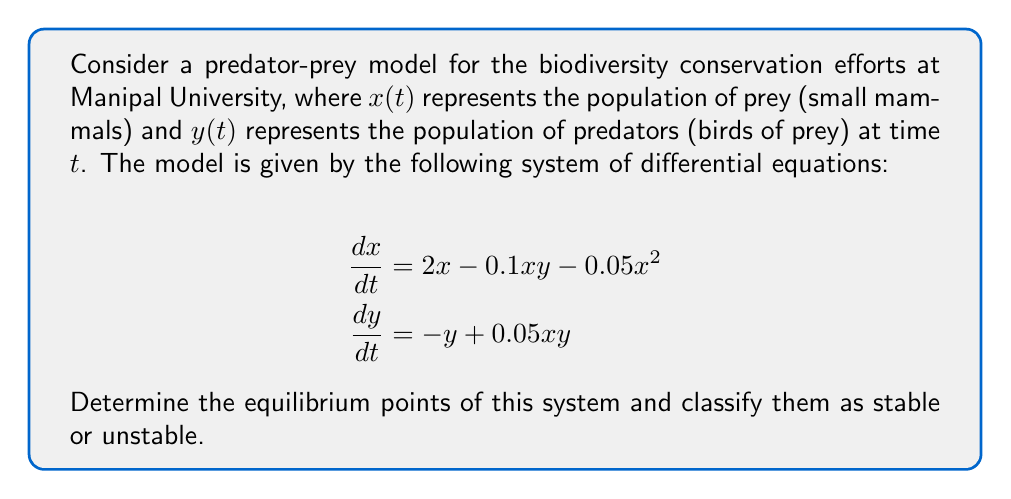Could you help me with this problem? To find the equilibrium points, we set both equations equal to zero and solve for $x$ and $y$:

1) Set $\frac{dx}{dt} = 0$ and $\frac{dy}{dt} = 0$:
   $$\begin{align}
   0 &= 2x - 0.1xy - 0.05x^2 \\
   0 &= -y + 0.05xy
   \end{align}$$

2) From the second equation:
   $y = 0.05xy$
   $y(1 - 0.05x) = 0$
   So, either $y = 0$ or $x = 20$

3) If $y = 0$, substitute into the first equation:
   $0 = 2x - 0.05x^2$
   $x(2 - 0.05x) = 0$
   So, $x = 0$ or $x = 40$

4) If $x = 20$, substitute into the second equation:
   $y = 0.05 \cdot 20y = y$
   This is true for any $y$. Substitute $x = 20$ into the first equation:
   $0 = 40 - 2y - 20$
   $y = 10$

5) Therefore, we have three equilibrium points: $(0,0)$, $(40,0)$, and $(20,10)$

To classify stability, we need to find the Jacobian matrix and evaluate it at each point:

$$J = \begin{bmatrix}
2 - 0.1y - 0.1x & -0.1x \\
0.05y & -1 + 0.05x
\end{bmatrix}$$

6) At $(0,0)$: $J(0,0) = \begin{bmatrix} 2 & 0 \\ 0 & -1 \end{bmatrix}$
   Eigenvalues: 2 and -1. This is an unstable saddle point.

7) At $(40,0)$: $J(40,0) = \begin{bmatrix} -2 & -4 \\ 0 & 1 \end{bmatrix}$
   Eigenvalues: -2 and 1. This is an unstable saddle point.

8) At $(20,10)$: $J(20,10) = \begin{bmatrix} -1 & -2 \\ 0.5 & 0 \end{bmatrix}$
   Characteristic equation: $\lambda^2 + \lambda + 1 = 0$
   Eigenvalues: $\lambda = \frac{-1 \pm \sqrt{3}i}{2}$
   This is a stable spiral point.
Answer: Equilibrium points: $(0,0)$ (unstable), $(40,0)$ (unstable), $(20,10)$ (stable spiral) 